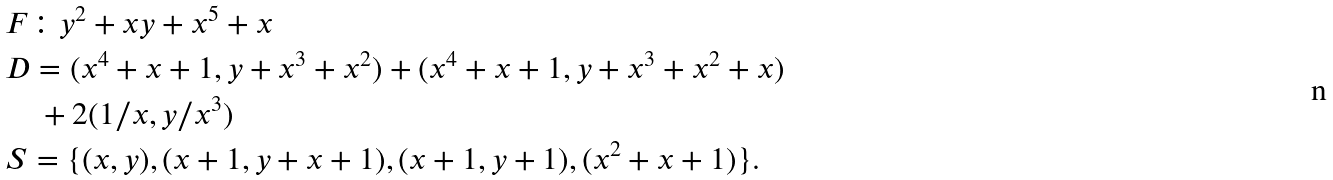Convert formula to latex. <formula><loc_0><loc_0><loc_500><loc_500>& F \colon y ^ { 2 } + x y + x ^ { 5 } + x \\ & D = ( x ^ { 4 } + x + 1 , y + x ^ { 3 } + x ^ { 2 } ) + ( x ^ { 4 } + x + 1 , y + x ^ { 3 } + x ^ { 2 } + x ) \\ & \quad + 2 ( 1 / x , y / x ^ { 3 } ) \\ & S = \{ ( x , y ) , ( x + 1 , y + x + 1 ) , ( x + 1 , y + 1 ) , ( x ^ { 2 } + x + 1 ) \} .</formula> 